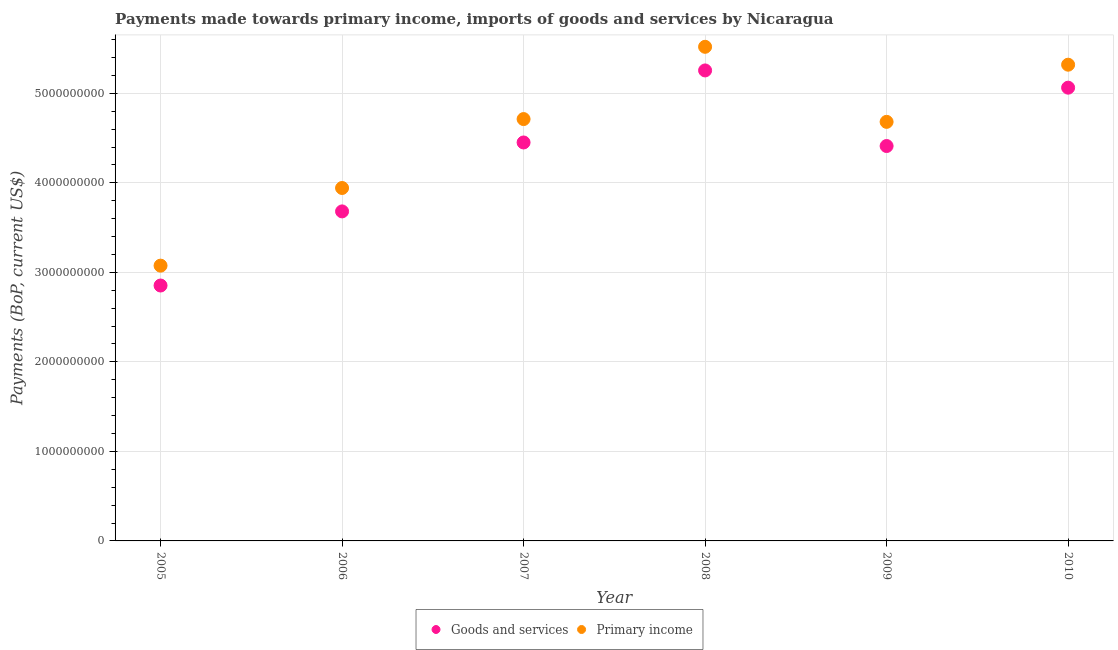Is the number of dotlines equal to the number of legend labels?
Your answer should be very brief. Yes. What is the payments made towards goods and services in 2007?
Keep it short and to the point. 4.45e+09. Across all years, what is the maximum payments made towards goods and services?
Provide a short and direct response. 5.26e+09. Across all years, what is the minimum payments made towards primary income?
Provide a succinct answer. 3.07e+09. In which year was the payments made towards primary income maximum?
Keep it short and to the point. 2008. What is the total payments made towards primary income in the graph?
Keep it short and to the point. 2.72e+1. What is the difference between the payments made towards goods and services in 2006 and that in 2009?
Give a very brief answer. -7.30e+08. What is the difference between the payments made towards primary income in 2007 and the payments made towards goods and services in 2008?
Offer a terse response. -5.43e+08. What is the average payments made towards primary income per year?
Make the answer very short. 4.54e+09. In the year 2006, what is the difference between the payments made towards goods and services and payments made towards primary income?
Ensure brevity in your answer.  -2.62e+08. What is the ratio of the payments made towards goods and services in 2005 to that in 2009?
Give a very brief answer. 0.65. Is the payments made towards primary income in 2007 less than that in 2010?
Your response must be concise. Yes. Is the difference between the payments made towards goods and services in 2005 and 2008 greater than the difference between the payments made towards primary income in 2005 and 2008?
Keep it short and to the point. Yes. What is the difference between the highest and the second highest payments made towards primary income?
Provide a short and direct response. 2.00e+08. What is the difference between the highest and the lowest payments made towards primary income?
Make the answer very short. 2.44e+09. In how many years, is the payments made towards primary income greater than the average payments made towards primary income taken over all years?
Provide a short and direct response. 4. Is the sum of the payments made towards goods and services in 2005 and 2006 greater than the maximum payments made towards primary income across all years?
Provide a succinct answer. Yes. Is the payments made towards primary income strictly greater than the payments made towards goods and services over the years?
Make the answer very short. Yes. How many years are there in the graph?
Your response must be concise. 6. What is the difference between two consecutive major ticks on the Y-axis?
Keep it short and to the point. 1.00e+09. Does the graph contain any zero values?
Your response must be concise. No. Where does the legend appear in the graph?
Provide a short and direct response. Bottom center. How many legend labels are there?
Provide a short and direct response. 2. What is the title of the graph?
Your answer should be compact. Payments made towards primary income, imports of goods and services by Nicaragua. What is the label or title of the X-axis?
Your answer should be very brief. Year. What is the label or title of the Y-axis?
Your answer should be very brief. Payments (BoP, current US$). What is the Payments (BoP, current US$) in Goods and services in 2005?
Give a very brief answer. 2.85e+09. What is the Payments (BoP, current US$) of Primary income in 2005?
Your response must be concise. 3.07e+09. What is the Payments (BoP, current US$) in Goods and services in 2006?
Give a very brief answer. 3.68e+09. What is the Payments (BoP, current US$) in Primary income in 2006?
Your answer should be compact. 3.94e+09. What is the Payments (BoP, current US$) of Goods and services in 2007?
Ensure brevity in your answer.  4.45e+09. What is the Payments (BoP, current US$) of Primary income in 2007?
Provide a short and direct response. 4.71e+09. What is the Payments (BoP, current US$) in Goods and services in 2008?
Offer a terse response. 5.26e+09. What is the Payments (BoP, current US$) in Primary income in 2008?
Offer a very short reply. 5.52e+09. What is the Payments (BoP, current US$) of Goods and services in 2009?
Your answer should be compact. 4.41e+09. What is the Payments (BoP, current US$) in Primary income in 2009?
Provide a short and direct response. 4.68e+09. What is the Payments (BoP, current US$) in Goods and services in 2010?
Provide a succinct answer. 5.06e+09. What is the Payments (BoP, current US$) of Primary income in 2010?
Your answer should be compact. 5.32e+09. Across all years, what is the maximum Payments (BoP, current US$) in Goods and services?
Your answer should be very brief. 5.26e+09. Across all years, what is the maximum Payments (BoP, current US$) of Primary income?
Offer a very short reply. 5.52e+09. Across all years, what is the minimum Payments (BoP, current US$) of Goods and services?
Keep it short and to the point. 2.85e+09. Across all years, what is the minimum Payments (BoP, current US$) of Primary income?
Ensure brevity in your answer.  3.07e+09. What is the total Payments (BoP, current US$) in Goods and services in the graph?
Keep it short and to the point. 2.57e+1. What is the total Payments (BoP, current US$) in Primary income in the graph?
Your response must be concise. 2.72e+1. What is the difference between the Payments (BoP, current US$) in Goods and services in 2005 and that in 2006?
Provide a succinct answer. -8.28e+08. What is the difference between the Payments (BoP, current US$) of Primary income in 2005 and that in 2006?
Keep it short and to the point. -8.67e+08. What is the difference between the Payments (BoP, current US$) of Goods and services in 2005 and that in 2007?
Keep it short and to the point. -1.60e+09. What is the difference between the Payments (BoP, current US$) of Primary income in 2005 and that in 2007?
Your answer should be very brief. -1.64e+09. What is the difference between the Payments (BoP, current US$) in Goods and services in 2005 and that in 2008?
Give a very brief answer. -2.40e+09. What is the difference between the Payments (BoP, current US$) of Primary income in 2005 and that in 2008?
Provide a succinct answer. -2.44e+09. What is the difference between the Payments (BoP, current US$) in Goods and services in 2005 and that in 2009?
Give a very brief answer. -1.56e+09. What is the difference between the Payments (BoP, current US$) of Primary income in 2005 and that in 2009?
Provide a short and direct response. -1.61e+09. What is the difference between the Payments (BoP, current US$) in Goods and services in 2005 and that in 2010?
Your response must be concise. -2.21e+09. What is the difference between the Payments (BoP, current US$) in Primary income in 2005 and that in 2010?
Your response must be concise. -2.24e+09. What is the difference between the Payments (BoP, current US$) in Goods and services in 2006 and that in 2007?
Make the answer very short. -7.70e+08. What is the difference between the Payments (BoP, current US$) of Primary income in 2006 and that in 2007?
Your response must be concise. -7.70e+08. What is the difference between the Payments (BoP, current US$) of Goods and services in 2006 and that in 2008?
Offer a terse response. -1.57e+09. What is the difference between the Payments (BoP, current US$) of Primary income in 2006 and that in 2008?
Offer a terse response. -1.58e+09. What is the difference between the Payments (BoP, current US$) in Goods and services in 2006 and that in 2009?
Your response must be concise. -7.30e+08. What is the difference between the Payments (BoP, current US$) of Primary income in 2006 and that in 2009?
Ensure brevity in your answer.  -7.39e+08. What is the difference between the Payments (BoP, current US$) of Goods and services in 2006 and that in 2010?
Offer a very short reply. -1.38e+09. What is the difference between the Payments (BoP, current US$) of Primary income in 2006 and that in 2010?
Offer a terse response. -1.38e+09. What is the difference between the Payments (BoP, current US$) of Goods and services in 2007 and that in 2008?
Your answer should be compact. -8.05e+08. What is the difference between the Payments (BoP, current US$) in Primary income in 2007 and that in 2008?
Offer a very short reply. -8.07e+08. What is the difference between the Payments (BoP, current US$) of Goods and services in 2007 and that in 2009?
Your answer should be very brief. 3.97e+07. What is the difference between the Payments (BoP, current US$) in Primary income in 2007 and that in 2009?
Your answer should be very brief. 3.12e+07. What is the difference between the Payments (BoP, current US$) of Goods and services in 2007 and that in 2010?
Offer a very short reply. -6.12e+08. What is the difference between the Payments (BoP, current US$) in Primary income in 2007 and that in 2010?
Offer a very short reply. -6.07e+08. What is the difference between the Payments (BoP, current US$) of Goods and services in 2008 and that in 2009?
Provide a short and direct response. 8.44e+08. What is the difference between the Payments (BoP, current US$) of Primary income in 2008 and that in 2009?
Offer a terse response. 8.38e+08. What is the difference between the Payments (BoP, current US$) in Goods and services in 2008 and that in 2010?
Offer a terse response. 1.92e+08. What is the difference between the Payments (BoP, current US$) in Primary income in 2008 and that in 2010?
Your answer should be very brief. 2.00e+08. What is the difference between the Payments (BoP, current US$) of Goods and services in 2009 and that in 2010?
Offer a terse response. -6.52e+08. What is the difference between the Payments (BoP, current US$) of Primary income in 2009 and that in 2010?
Ensure brevity in your answer.  -6.38e+08. What is the difference between the Payments (BoP, current US$) in Goods and services in 2005 and the Payments (BoP, current US$) in Primary income in 2006?
Your answer should be very brief. -1.09e+09. What is the difference between the Payments (BoP, current US$) of Goods and services in 2005 and the Payments (BoP, current US$) of Primary income in 2007?
Keep it short and to the point. -1.86e+09. What is the difference between the Payments (BoP, current US$) of Goods and services in 2005 and the Payments (BoP, current US$) of Primary income in 2008?
Keep it short and to the point. -2.67e+09. What is the difference between the Payments (BoP, current US$) of Goods and services in 2005 and the Payments (BoP, current US$) of Primary income in 2009?
Your response must be concise. -1.83e+09. What is the difference between the Payments (BoP, current US$) of Goods and services in 2005 and the Payments (BoP, current US$) of Primary income in 2010?
Offer a very short reply. -2.47e+09. What is the difference between the Payments (BoP, current US$) of Goods and services in 2006 and the Payments (BoP, current US$) of Primary income in 2007?
Offer a terse response. -1.03e+09. What is the difference between the Payments (BoP, current US$) of Goods and services in 2006 and the Payments (BoP, current US$) of Primary income in 2008?
Your answer should be compact. -1.84e+09. What is the difference between the Payments (BoP, current US$) of Goods and services in 2006 and the Payments (BoP, current US$) of Primary income in 2009?
Provide a succinct answer. -1.00e+09. What is the difference between the Payments (BoP, current US$) of Goods and services in 2006 and the Payments (BoP, current US$) of Primary income in 2010?
Offer a terse response. -1.64e+09. What is the difference between the Payments (BoP, current US$) of Goods and services in 2007 and the Payments (BoP, current US$) of Primary income in 2008?
Your answer should be very brief. -1.07e+09. What is the difference between the Payments (BoP, current US$) in Goods and services in 2007 and the Payments (BoP, current US$) in Primary income in 2009?
Your response must be concise. -2.30e+08. What is the difference between the Payments (BoP, current US$) of Goods and services in 2007 and the Payments (BoP, current US$) of Primary income in 2010?
Your answer should be compact. -8.69e+08. What is the difference between the Payments (BoP, current US$) in Goods and services in 2008 and the Payments (BoP, current US$) in Primary income in 2009?
Provide a short and direct response. 5.74e+08. What is the difference between the Payments (BoP, current US$) in Goods and services in 2008 and the Payments (BoP, current US$) in Primary income in 2010?
Ensure brevity in your answer.  -6.41e+07. What is the difference between the Payments (BoP, current US$) of Goods and services in 2009 and the Payments (BoP, current US$) of Primary income in 2010?
Ensure brevity in your answer.  -9.08e+08. What is the average Payments (BoP, current US$) of Goods and services per year?
Your answer should be compact. 4.29e+09. What is the average Payments (BoP, current US$) in Primary income per year?
Ensure brevity in your answer.  4.54e+09. In the year 2005, what is the difference between the Payments (BoP, current US$) in Goods and services and Payments (BoP, current US$) in Primary income?
Your response must be concise. -2.22e+08. In the year 2006, what is the difference between the Payments (BoP, current US$) in Goods and services and Payments (BoP, current US$) in Primary income?
Your answer should be very brief. -2.62e+08. In the year 2007, what is the difference between the Payments (BoP, current US$) in Goods and services and Payments (BoP, current US$) in Primary income?
Give a very brief answer. -2.61e+08. In the year 2008, what is the difference between the Payments (BoP, current US$) in Goods and services and Payments (BoP, current US$) in Primary income?
Give a very brief answer. -2.64e+08. In the year 2009, what is the difference between the Payments (BoP, current US$) in Goods and services and Payments (BoP, current US$) in Primary income?
Keep it short and to the point. -2.70e+08. In the year 2010, what is the difference between the Payments (BoP, current US$) in Goods and services and Payments (BoP, current US$) in Primary income?
Offer a very short reply. -2.57e+08. What is the ratio of the Payments (BoP, current US$) in Goods and services in 2005 to that in 2006?
Ensure brevity in your answer.  0.78. What is the ratio of the Payments (BoP, current US$) of Primary income in 2005 to that in 2006?
Your answer should be very brief. 0.78. What is the ratio of the Payments (BoP, current US$) in Goods and services in 2005 to that in 2007?
Offer a terse response. 0.64. What is the ratio of the Payments (BoP, current US$) of Primary income in 2005 to that in 2007?
Keep it short and to the point. 0.65. What is the ratio of the Payments (BoP, current US$) of Goods and services in 2005 to that in 2008?
Keep it short and to the point. 0.54. What is the ratio of the Payments (BoP, current US$) in Primary income in 2005 to that in 2008?
Your answer should be compact. 0.56. What is the ratio of the Payments (BoP, current US$) of Goods and services in 2005 to that in 2009?
Give a very brief answer. 0.65. What is the ratio of the Payments (BoP, current US$) of Primary income in 2005 to that in 2009?
Your response must be concise. 0.66. What is the ratio of the Payments (BoP, current US$) of Goods and services in 2005 to that in 2010?
Make the answer very short. 0.56. What is the ratio of the Payments (BoP, current US$) of Primary income in 2005 to that in 2010?
Make the answer very short. 0.58. What is the ratio of the Payments (BoP, current US$) in Goods and services in 2006 to that in 2007?
Your answer should be very brief. 0.83. What is the ratio of the Payments (BoP, current US$) in Primary income in 2006 to that in 2007?
Offer a very short reply. 0.84. What is the ratio of the Payments (BoP, current US$) of Goods and services in 2006 to that in 2008?
Offer a terse response. 0.7. What is the ratio of the Payments (BoP, current US$) in Goods and services in 2006 to that in 2009?
Offer a very short reply. 0.83. What is the ratio of the Payments (BoP, current US$) in Primary income in 2006 to that in 2009?
Your answer should be very brief. 0.84. What is the ratio of the Payments (BoP, current US$) in Goods and services in 2006 to that in 2010?
Your answer should be compact. 0.73. What is the ratio of the Payments (BoP, current US$) in Primary income in 2006 to that in 2010?
Your response must be concise. 0.74. What is the ratio of the Payments (BoP, current US$) of Goods and services in 2007 to that in 2008?
Your response must be concise. 0.85. What is the ratio of the Payments (BoP, current US$) of Primary income in 2007 to that in 2008?
Ensure brevity in your answer.  0.85. What is the ratio of the Payments (BoP, current US$) in Goods and services in 2007 to that in 2010?
Offer a very short reply. 0.88. What is the ratio of the Payments (BoP, current US$) of Primary income in 2007 to that in 2010?
Offer a terse response. 0.89. What is the ratio of the Payments (BoP, current US$) of Goods and services in 2008 to that in 2009?
Your answer should be very brief. 1.19. What is the ratio of the Payments (BoP, current US$) of Primary income in 2008 to that in 2009?
Keep it short and to the point. 1.18. What is the ratio of the Payments (BoP, current US$) of Goods and services in 2008 to that in 2010?
Offer a terse response. 1.04. What is the ratio of the Payments (BoP, current US$) in Primary income in 2008 to that in 2010?
Keep it short and to the point. 1.04. What is the ratio of the Payments (BoP, current US$) in Goods and services in 2009 to that in 2010?
Make the answer very short. 0.87. What is the ratio of the Payments (BoP, current US$) of Primary income in 2009 to that in 2010?
Ensure brevity in your answer.  0.88. What is the difference between the highest and the second highest Payments (BoP, current US$) of Goods and services?
Your answer should be compact. 1.92e+08. What is the difference between the highest and the second highest Payments (BoP, current US$) in Primary income?
Provide a succinct answer. 2.00e+08. What is the difference between the highest and the lowest Payments (BoP, current US$) of Goods and services?
Ensure brevity in your answer.  2.40e+09. What is the difference between the highest and the lowest Payments (BoP, current US$) in Primary income?
Offer a very short reply. 2.44e+09. 